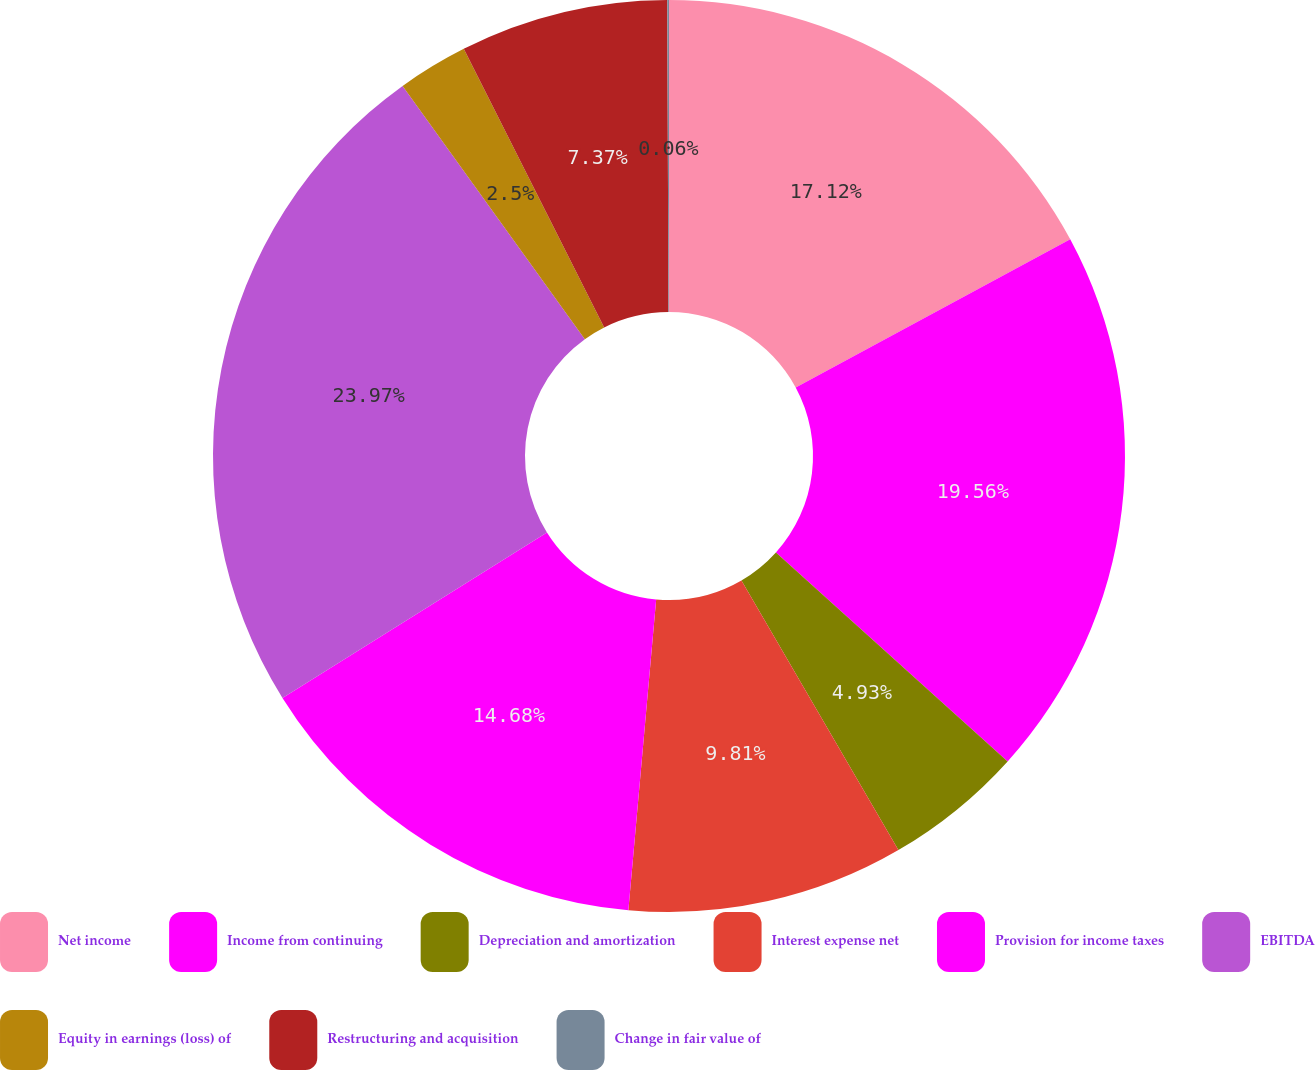Convert chart. <chart><loc_0><loc_0><loc_500><loc_500><pie_chart><fcel>Net income<fcel>Income from continuing<fcel>Depreciation and amortization<fcel>Interest expense net<fcel>Provision for income taxes<fcel>EBITDA<fcel>Equity in earnings (loss) of<fcel>Restructuring and acquisition<fcel>Change in fair value of<nl><fcel>17.12%<fcel>19.56%<fcel>4.93%<fcel>9.81%<fcel>14.68%<fcel>23.97%<fcel>2.5%<fcel>7.37%<fcel>0.06%<nl></chart> 